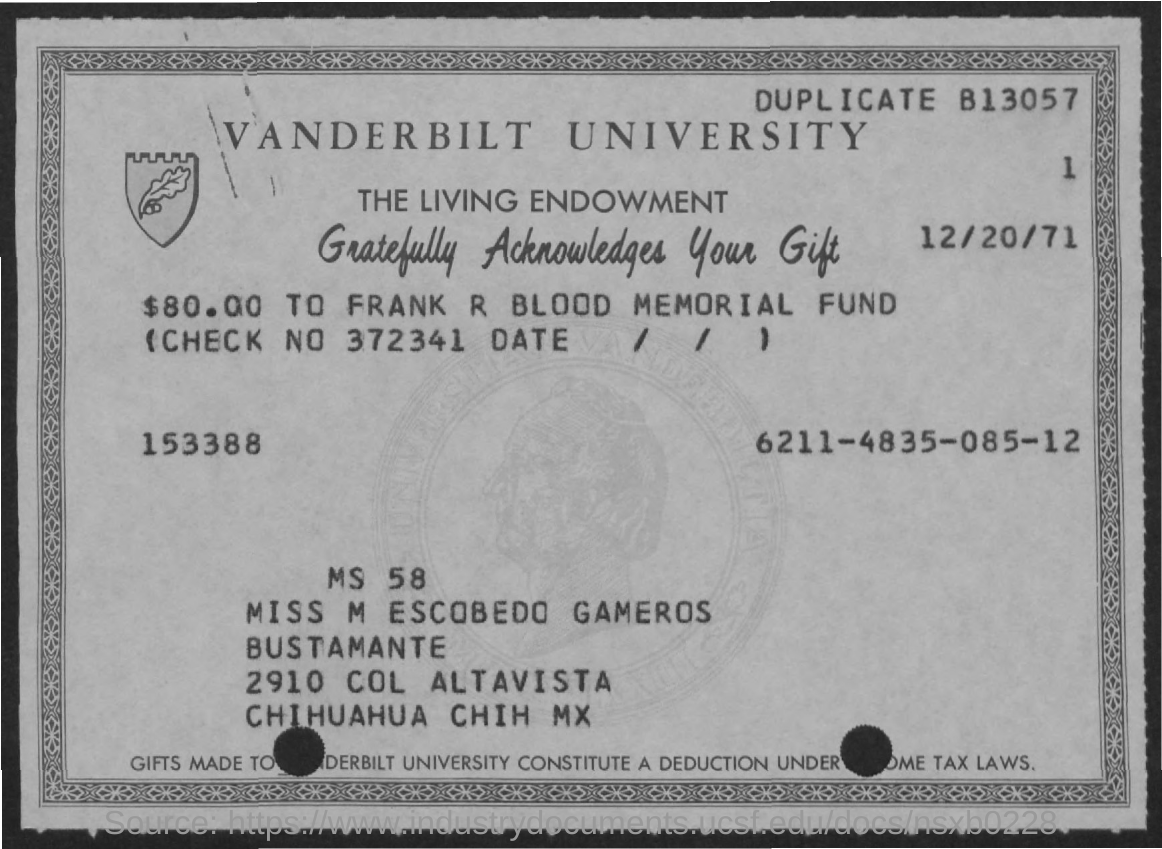What is the date mentioned ?
Provide a succinct answer. 12/20/71. What is the check no. mentioned ?
Provide a succinct answer. 372341. What is the amount mentioned in the given page ?
Keep it short and to the point. $80.00. What is the name of the university mentioned ?
Provide a succinct answer. Vanderbilt university. 